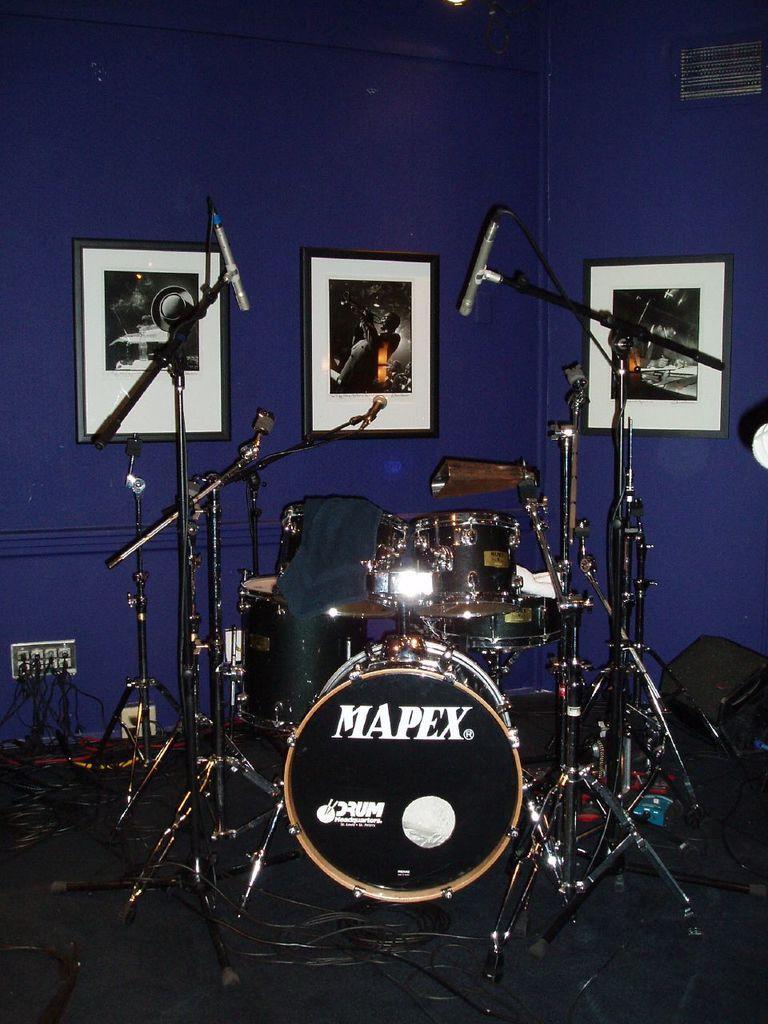In one or two sentences, can you explain what this image depicts? This image consists of a band setup along with the mics. In the background, there are three frames hanged on the wall. The wall is in blue color. At the bottom, there is a floor. 